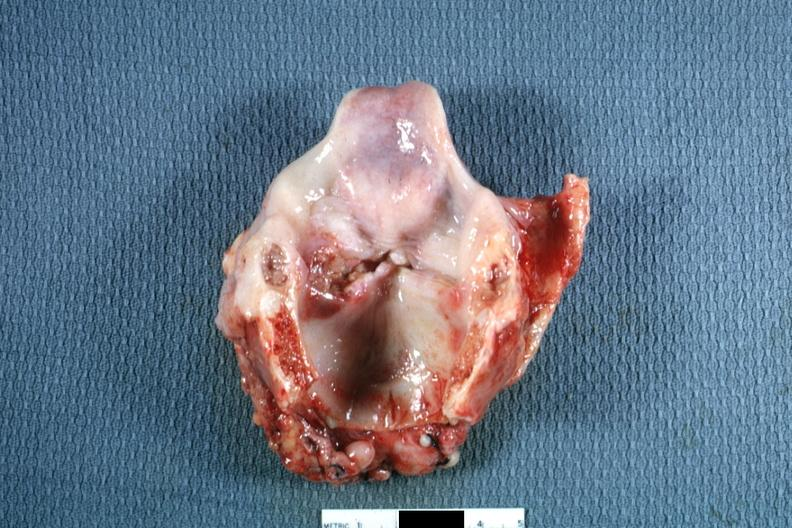where is this?
Answer the question using a single word or phrase. Oral 